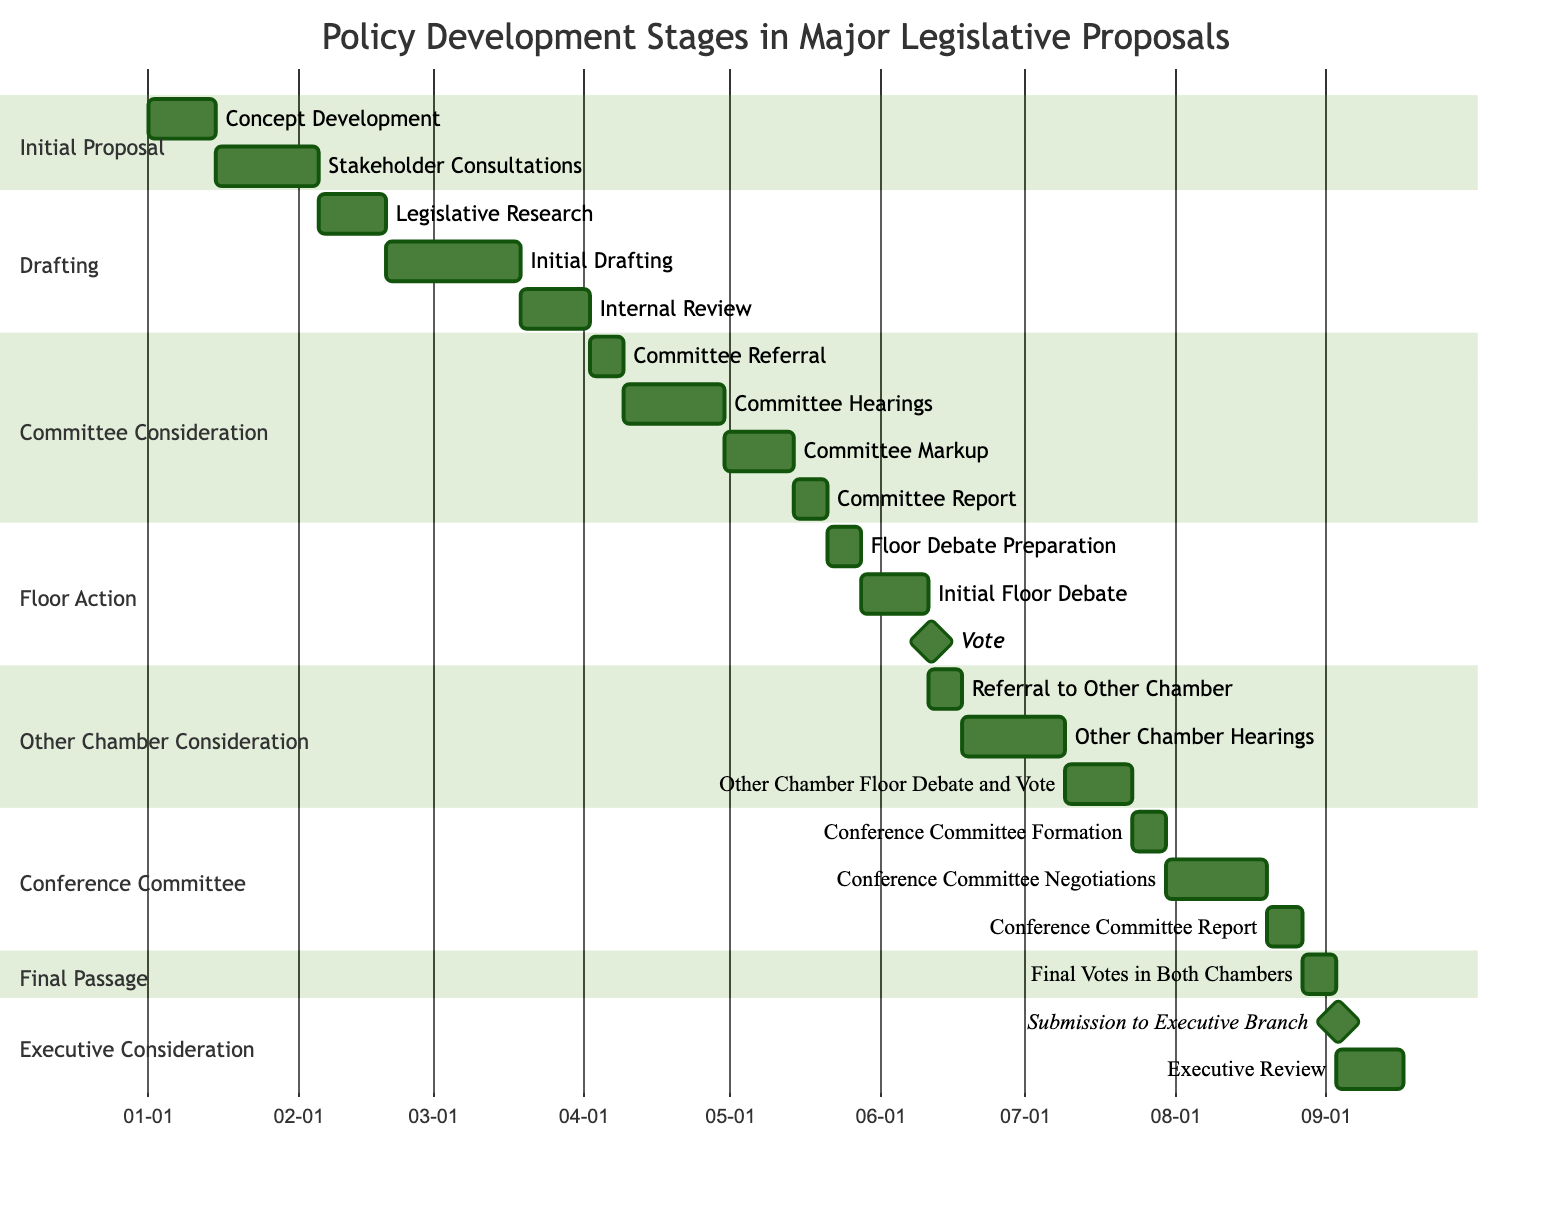What is the duration of the "Stakeholder Consultations" task? The "Stakeholder Consultations" task is listed under the "Initial Proposal" stage, with a duration of 3 weeks.
Answer: 3 weeks How many tasks are included in the "Committee Consideration" stage? The "Committee Consideration" stage has 4 tasks: Committee Referral, Committee Hearings, Committee Markup, and Committee Report, summing up to a total of 4 tasks.
Answer: 4 tasks What task follows "Initial Drafting"? According to the diagram, "Internal Review" follows "Initial Drafting," as indicated by the sequential order shown under the "Drafting" stage.
Answer: Internal Review How long do the tasks in the "Executive Consideration" section take in total? In the "Executive Consideration" section, the total duration is calculated as 1 day for submission and 2 weeks for executive review, which adds up to a total of approximately 15 days (since 1 day is part of the 2 weeks).
Answer: 15 days What is the relationship between "Other Chamber Floor Debate and Vote" and "Conference Committee Report"? "Other Chamber Floor Debate and Vote" occurs after "Conference Committee Report." This shows that the proposal must go through the conference committee before being voted on in the other chamber, indicating dependency.
Answer: Dependent What is the first task in the "Floor Action" stage? The first task listed in the "Floor Action" stage is "Floor Debate Preparation." This task is the initial step in this stage of policy development.
Answer: Floor Debate Preparation Which task serves as a milestone in the entire diagram? The "Vote" task in the "Floor Action" stage is indicated as a milestone, marking a significant point in the legislative process.
Answer: Vote How many weeks does the "Drafting" stage take in total? The "Drafting" stage comprises tasks totaling 8 weeks, calculated by adding the durations of Legislative Research (2 weeks), Initial Drafting (4 weeks), and Internal Review (2 weeks).
Answer: 8 weeks What stage includes "Committee Markup"? "Committee Markup" is included in the "Committee Consideration" stage, demonstrating that it is part of the committee's review process before finalizing the legislative proposal.
Answer: Committee Consideration 